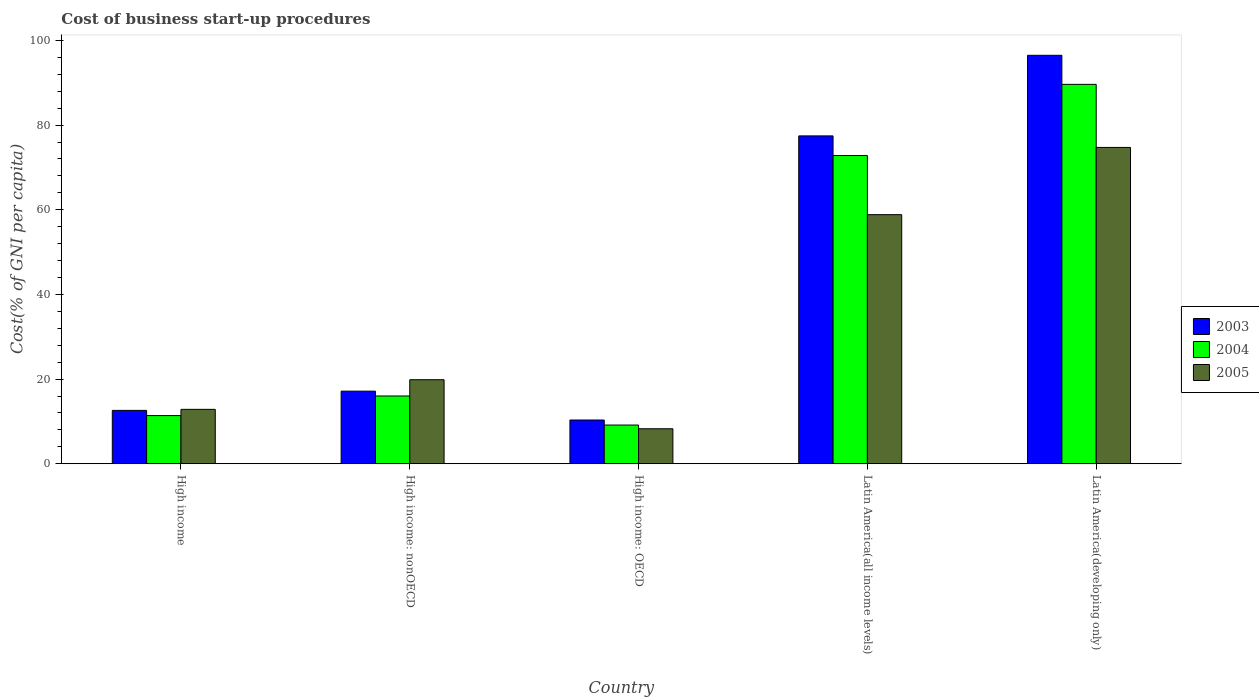Are the number of bars per tick equal to the number of legend labels?
Your answer should be very brief. Yes. Are the number of bars on each tick of the X-axis equal?
Your response must be concise. Yes. What is the cost of business start-up procedures in 2005 in High income: OECD?
Offer a terse response. 8.27. Across all countries, what is the maximum cost of business start-up procedures in 2005?
Make the answer very short. 74.73. Across all countries, what is the minimum cost of business start-up procedures in 2005?
Provide a short and direct response. 8.27. In which country was the cost of business start-up procedures in 2005 maximum?
Your answer should be very brief. Latin America(developing only). In which country was the cost of business start-up procedures in 2004 minimum?
Provide a succinct answer. High income: OECD. What is the total cost of business start-up procedures in 2003 in the graph?
Provide a succinct answer. 214.03. What is the difference between the cost of business start-up procedures in 2005 in High income and that in Latin America(all income levels)?
Make the answer very short. -45.99. What is the difference between the cost of business start-up procedures in 2003 in High income and the cost of business start-up procedures in 2005 in Latin America(developing only)?
Give a very brief answer. -62.12. What is the average cost of business start-up procedures in 2005 per country?
Ensure brevity in your answer.  34.91. What is the difference between the cost of business start-up procedures of/in 2005 and cost of business start-up procedures of/in 2004 in High income?
Offer a terse response. 1.47. What is the ratio of the cost of business start-up procedures in 2003 in High income to that in Latin America(developing only)?
Keep it short and to the point. 0.13. Is the cost of business start-up procedures in 2005 in High income: nonOECD less than that in Latin America(developing only)?
Give a very brief answer. Yes. What is the difference between the highest and the second highest cost of business start-up procedures in 2003?
Give a very brief answer. 79.34. What is the difference between the highest and the lowest cost of business start-up procedures in 2005?
Make the answer very short. 66.46. In how many countries, is the cost of business start-up procedures in 2004 greater than the average cost of business start-up procedures in 2004 taken over all countries?
Give a very brief answer. 2. What does the 2nd bar from the right in High income represents?
Offer a terse response. 2004. Is it the case that in every country, the sum of the cost of business start-up procedures in 2003 and cost of business start-up procedures in 2005 is greater than the cost of business start-up procedures in 2004?
Provide a succinct answer. Yes. How many bars are there?
Give a very brief answer. 15. Are the values on the major ticks of Y-axis written in scientific E-notation?
Offer a terse response. No. Does the graph contain grids?
Your answer should be very brief. No. How many legend labels are there?
Your response must be concise. 3. How are the legend labels stacked?
Provide a succinct answer. Vertical. What is the title of the graph?
Offer a terse response. Cost of business start-up procedures. Does "1973" appear as one of the legend labels in the graph?
Your answer should be compact. No. What is the label or title of the X-axis?
Give a very brief answer. Country. What is the label or title of the Y-axis?
Ensure brevity in your answer.  Cost(% of GNI per capita). What is the Cost(% of GNI per capita) in 2003 in High income?
Your response must be concise. 12.6. What is the Cost(% of GNI per capita) in 2004 in High income?
Provide a short and direct response. 11.38. What is the Cost(% of GNI per capita) of 2005 in High income?
Provide a succinct answer. 12.85. What is the Cost(% of GNI per capita) of 2003 in High income: nonOECD?
Keep it short and to the point. 17.15. What is the Cost(% of GNI per capita) of 2004 in High income: nonOECD?
Provide a succinct answer. 16.01. What is the Cost(% of GNI per capita) of 2005 in High income: nonOECD?
Your answer should be very brief. 19.85. What is the Cost(% of GNI per capita) in 2003 in High income: OECD?
Your answer should be compact. 10.33. What is the Cost(% of GNI per capita) of 2004 in High income: OECD?
Offer a terse response. 9.14. What is the Cost(% of GNI per capita) of 2005 in High income: OECD?
Ensure brevity in your answer.  8.27. What is the Cost(% of GNI per capita) in 2003 in Latin America(all income levels)?
Your answer should be compact. 77.45. What is the Cost(% of GNI per capita) of 2004 in Latin America(all income levels)?
Give a very brief answer. 72.81. What is the Cost(% of GNI per capita) in 2005 in Latin America(all income levels)?
Make the answer very short. 58.84. What is the Cost(% of GNI per capita) of 2003 in Latin America(developing only)?
Offer a terse response. 96.49. What is the Cost(% of GNI per capita) of 2004 in Latin America(developing only)?
Provide a succinct answer. 89.63. What is the Cost(% of GNI per capita) of 2005 in Latin America(developing only)?
Your response must be concise. 74.73. Across all countries, what is the maximum Cost(% of GNI per capita) in 2003?
Provide a short and direct response. 96.49. Across all countries, what is the maximum Cost(% of GNI per capita) in 2004?
Provide a succinct answer. 89.63. Across all countries, what is the maximum Cost(% of GNI per capita) of 2005?
Provide a succinct answer. 74.73. Across all countries, what is the minimum Cost(% of GNI per capita) in 2003?
Your response must be concise. 10.33. Across all countries, what is the minimum Cost(% of GNI per capita) of 2004?
Provide a succinct answer. 9.14. Across all countries, what is the minimum Cost(% of GNI per capita) of 2005?
Ensure brevity in your answer.  8.27. What is the total Cost(% of GNI per capita) in 2003 in the graph?
Give a very brief answer. 214.03. What is the total Cost(% of GNI per capita) in 2004 in the graph?
Your answer should be very brief. 198.96. What is the total Cost(% of GNI per capita) of 2005 in the graph?
Offer a very short reply. 174.53. What is the difference between the Cost(% of GNI per capita) of 2003 in High income and that in High income: nonOECD?
Offer a terse response. -4.55. What is the difference between the Cost(% of GNI per capita) in 2004 in High income and that in High income: nonOECD?
Your response must be concise. -4.63. What is the difference between the Cost(% of GNI per capita) of 2005 in High income and that in High income: nonOECD?
Provide a short and direct response. -7. What is the difference between the Cost(% of GNI per capita) in 2003 in High income and that in High income: OECD?
Keep it short and to the point. 2.27. What is the difference between the Cost(% of GNI per capita) in 2004 in High income and that in High income: OECD?
Give a very brief answer. 2.24. What is the difference between the Cost(% of GNI per capita) of 2005 in High income and that in High income: OECD?
Your answer should be compact. 4.58. What is the difference between the Cost(% of GNI per capita) of 2003 in High income and that in Latin America(all income levels)?
Provide a short and direct response. -64.85. What is the difference between the Cost(% of GNI per capita) in 2004 in High income and that in Latin America(all income levels)?
Keep it short and to the point. -61.43. What is the difference between the Cost(% of GNI per capita) of 2005 in High income and that in Latin America(all income levels)?
Give a very brief answer. -45.99. What is the difference between the Cost(% of GNI per capita) of 2003 in High income and that in Latin America(developing only)?
Your answer should be very brief. -83.89. What is the difference between the Cost(% of GNI per capita) of 2004 in High income and that in Latin America(developing only)?
Offer a very short reply. -78.25. What is the difference between the Cost(% of GNI per capita) of 2005 in High income and that in Latin America(developing only)?
Your response must be concise. -61.88. What is the difference between the Cost(% of GNI per capita) of 2003 in High income: nonOECD and that in High income: OECD?
Offer a terse response. 6.82. What is the difference between the Cost(% of GNI per capita) of 2004 in High income: nonOECD and that in High income: OECD?
Provide a succinct answer. 6.87. What is the difference between the Cost(% of GNI per capita) of 2005 in High income: nonOECD and that in High income: OECD?
Give a very brief answer. 11.58. What is the difference between the Cost(% of GNI per capita) in 2003 in High income: nonOECD and that in Latin America(all income levels)?
Keep it short and to the point. -60.3. What is the difference between the Cost(% of GNI per capita) of 2004 in High income: nonOECD and that in Latin America(all income levels)?
Offer a very short reply. -56.8. What is the difference between the Cost(% of GNI per capita) in 2005 in High income: nonOECD and that in Latin America(all income levels)?
Make the answer very short. -38.99. What is the difference between the Cost(% of GNI per capita) of 2003 in High income: nonOECD and that in Latin America(developing only)?
Your answer should be very brief. -79.34. What is the difference between the Cost(% of GNI per capita) of 2004 in High income: nonOECD and that in Latin America(developing only)?
Keep it short and to the point. -73.62. What is the difference between the Cost(% of GNI per capita) of 2005 in High income: nonOECD and that in Latin America(developing only)?
Make the answer very short. -54.88. What is the difference between the Cost(% of GNI per capita) of 2003 in High income: OECD and that in Latin America(all income levels)?
Ensure brevity in your answer.  -67.12. What is the difference between the Cost(% of GNI per capita) of 2004 in High income: OECD and that in Latin America(all income levels)?
Offer a very short reply. -63.67. What is the difference between the Cost(% of GNI per capita) in 2005 in High income: OECD and that in Latin America(all income levels)?
Provide a short and direct response. -50.58. What is the difference between the Cost(% of GNI per capita) in 2003 in High income: OECD and that in Latin America(developing only)?
Offer a terse response. -86.16. What is the difference between the Cost(% of GNI per capita) of 2004 in High income: OECD and that in Latin America(developing only)?
Offer a very short reply. -80.49. What is the difference between the Cost(% of GNI per capita) of 2005 in High income: OECD and that in Latin America(developing only)?
Keep it short and to the point. -66.46. What is the difference between the Cost(% of GNI per capita) of 2003 in Latin America(all income levels) and that in Latin America(developing only)?
Ensure brevity in your answer.  -19.04. What is the difference between the Cost(% of GNI per capita) in 2004 in Latin America(all income levels) and that in Latin America(developing only)?
Provide a succinct answer. -16.82. What is the difference between the Cost(% of GNI per capita) of 2005 in Latin America(all income levels) and that in Latin America(developing only)?
Offer a terse response. -15.89. What is the difference between the Cost(% of GNI per capita) in 2003 in High income and the Cost(% of GNI per capita) in 2004 in High income: nonOECD?
Offer a terse response. -3.4. What is the difference between the Cost(% of GNI per capita) in 2003 in High income and the Cost(% of GNI per capita) in 2005 in High income: nonOECD?
Ensure brevity in your answer.  -7.24. What is the difference between the Cost(% of GNI per capita) of 2004 in High income and the Cost(% of GNI per capita) of 2005 in High income: nonOECD?
Ensure brevity in your answer.  -8.47. What is the difference between the Cost(% of GNI per capita) of 2003 in High income and the Cost(% of GNI per capita) of 2004 in High income: OECD?
Make the answer very short. 3.46. What is the difference between the Cost(% of GNI per capita) in 2003 in High income and the Cost(% of GNI per capita) in 2005 in High income: OECD?
Offer a very short reply. 4.34. What is the difference between the Cost(% of GNI per capita) in 2004 in High income and the Cost(% of GNI per capita) in 2005 in High income: OECD?
Provide a succinct answer. 3.11. What is the difference between the Cost(% of GNI per capita) of 2003 in High income and the Cost(% of GNI per capita) of 2004 in Latin America(all income levels)?
Give a very brief answer. -60.21. What is the difference between the Cost(% of GNI per capita) of 2003 in High income and the Cost(% of GNI per capita) of 2005 in Latin America(all income levels)?
Provide a short and direct response. -46.24. What is the difference between the Cost(% of GNI per capita) in 2004 in High income and the Cost(% of GNI per capita) in 2005 in Latin America(all income levels)?
Give a very brief answer. -47.46. What is the difference between the Cost(% of GNI per capita) of 2003 in High income and the Cost(% of GNI per capita) of 2004 in Latin America(developing only)?
Give a very brief answer. -77.02. What is the difference between the Cost(% of GNI per capita) of 2003 in High income and the Cost(% of GNI per capita) of 2005 in Latin America(developing only)?
Your response must be concise. -62.12. What is the difference between the Cost(% of GNI per capita) of 2004 in High income and the Cost(% of GNI per capita) of 2005 in Latin America(developing only)?
Your answer should be compact. -63.35. What is the difference between the Cost(% of GNI per capita) in 2003 in High income: nonOECD and the Cost(% of GNI per capita) in 2004 in High income: OECD?
Offer a very short reply. 8.01. What is the difference between the Cost(% of GNI per capita) of 2003 in High income: nonOECD and the Cost(% of GNI per capita) of 2005 in High income: OECD?
Your answer should be very brief. 8.88. What is the difference between the Cost(% of GNI per capita) in 2004 in High income: nonOECD and the Cost(% of GNI per capita) in 2005 in High income: OECD?
Provide a short and direct response. 7.74. What is the difference between the Cost(% of GNI per capita) in 2003 in High income: nonOECD and the Cost(% of GNI per capita) in 2004 in Latin America(all income levels)?
Offer a very short reply. -55.66. What is the difference between the Cost(% of GNI per capita) of 2003 in High income: nonOECD and the Cost(% of GNI per capita) of 2005 in Latin America(all income levels)?
Your answer should be very brief. -41.69. What is the difference between the Cost(% of GNI per capita) of 2004 in High income: nonOECD and the Cost(% of GNI per capita) of 2005 in Latin America(all income levels)?
Your answer should be very brief. -42.83. What is the difference between the Cost(% of GNI per capita) of 2003 in High income: nonOECD and the Cost(% of GNI per capita) of 2004 in Latin America(developing only)?
Your response must be concise. -72.48. What is the difference between the Cost(% of GNI per capita) of 2003 in High income: nonOECD and the Cost(% of GNI per capita) of 2005 in Latin America(developing only)?
Provide a short and direct response. -57.58. What is the difference between the Cost(% of GNI per capita) of 2004 in High income: nonOECD and the Cost(% of GNI per capita) of 2005 in Latin America(developing only)?
Ensure brevity in your answer.  -58.72. What is the difference between the Cost(% of GNI per capita) in 2003 in High income: OECD and the Cost(% of GNI per capita) in 2004 in Latin America(all income levels)?
Provide a short and direct response. -62.48. What is the difference between the Cost(% of GNI per capita) of 2003 in High income: OECD and the Cost(% of GNI per capita) of 2005 in Latin America(all income levels)?
Offer a very short reply. -48.51. What is the difference between the Cost(% of GNI per capita) in 2004 in High income: OECD and the Cost(% of GNI per capita) in 2005 in Latin America(all income levels)?
Your answer should be very brief. -49.7. What is the difference between the Cost(% of GNI per capita) of 2003 in High income: OECD and the Cost(% of GNI per capita) of 2004 in Latin America(developing only)?
Your response must be concise. -79.29. What is the difference between the Cost(% of GNI per capita) of 2003 in High income: OECD and the Cost(% of GNI per capita) of 2005 in Latin America(developing only)?
Provide a short and direct response. -64.4. What is the difference between the Cost(% of GNI per capita) in 2004 in High income: OECD and the Cost(% of GNI per capita) in 2005 in Latin America(developing only)?
Provide a short and direct response. -65.59. What is the difference between the Cost(% of GNI per capita) in 2003 in Latin America(all income levels) and the Cost(% of GNI per capita) in 2004 in Latin America(developing only)?
Provide a succinct answer. -12.17. What is the difference between the Cost(% of GNI per capita) in 2003 in Latin America(all income levels) and the Cost(% of GNI per capita) in 2005 in Latin America(developing only)?
Your answer should be very brief. 2.72. What is the difference between the Cost(% of GNI per capita) in 2004 in Latin America(all income levels) and the Cost(% of GNI per capita) in 2005 in Latin America(developing only)?
Offer a very short reply. -1.92. What is the average Cost(% of GNI per capita) of 2003 per country?
Your answer should be compact. 42.81. What is the average Cost(% of GNI per capita) in 2004 per country?
Your answer should be very brief. 39.79. What is the average Cost(% of GNI per capita) of 2005 per country?
Give a very brief answer. 34.91. What is the difference between the Cost(% of GNI per capita) in 2003 and Cost(% of GNI per capita) in 2004 in High income?
Your answer should be compact. 1.23. What is the difference between the Cost(% of GNI per capita) in 2003 and Cost(% of GNI per capita) in 2005 in High income?
Provide a short and direct response. -0.25. What is the difference between the Cost(% of GNI per capita) in 2004 and Cost(% of GNI per capita) in 2005 in High income?
Provide a short and direct response. -1.47. What is the difference between the Cost(% of GNI per capita) of 2003 and Cost(% of GNI per capita) of 2005 in High income: nonOECD?
Offer a very short reply. -2.7. What is the difference between the Cost(% of GNI per capita) in 2004 and Cost(% of GNI per capita) in 2005 in High income: nonOECD?
Make the answer very short. -3.84. What is the difference between the Cost(% of GNI per capita) in 2003 and Cost(% of GNI per capita) in 2004 in High income: OECD?
Keep it short and to the point. 1.19. What is the difference between the Cost(% of GNI per capita) in 2003 and Cost(% of GNI per capita) in 2005 in High income: OECD?
Your answer should be very brief. 2.07. What is the difference between the Cost(% of GNI per capita) in 2004 and Cost(% of GNI per capita) in 2005 in High income: OECD?
Offer a terse response. 0.88. What is the difference between the Cost(% of GNI per capita) of 2003 and Cost(% of GNI per capita) of 2004 in Latin America(all income levels)?
Offer a terse response. 4.64. What is the difference between the Cost(% of GNI per capita) of 2003 and Cost(% of GNI per capita) of 2005 in Latin America(all income levels)?
Your answer should be compact. 18.61. What is the difference between the Cost(% of GNI per capita) in 2004 and Cost(% of GNI per capita) in 2005 in Latin America(all income levels)?
Provide a short and direct response. 13.97. What is the difference between the Cost(% of GNI per capita) in 2003 and Cost(% of GNI per capita) in 2004 in Latin America(developing only)?
Your answer should be very brief. 6.87. What is the difference between the Cost(% of GNI per capita) in 2003 and Cost(% of GNI per capita) in 2005 in Latin America(developing only)?
Give a very brief answer. 21.76. What is the difference between the Cost(% of GNI per capita) in 2004 and Cost(% of GNI per capita) in 2005 in Latin America(developing only)?
Keep it short and to the point. 14.9. What is the ratio of the Cost(% of GNI per capita) in 2003 in High income to that in High income: nonOECD?
Ensure brevity in your answer.  0.73. What is the ratio of the Cost(% of GNI per capita) in 2004 in High income to that in High income: nonOECD?
Make the answer very short. 0.71. What is the ratio of the Cost(% of GNI per capita) in 2005 in High income to that in High income: nonOECD?
Your answer should be very brief. 0.65. What is the ratio of the Cost(% of GNI per capita) in 2003 in High income to that in High income: OECD?
Your response must be concise. 1.22. What is the ratio of the Cost(% of GNI per capita) in 2004 in High income to that in High income: OECD?
Your answer should be compact. 1.24. What is the ratio of the Cost(% of GNI per capita) of 2005 in High income to that in High income: OECD?
Your answer should be very brief. 1.55. What is the ratio of the Cost(% of GNI per capita) in 2003 in High income to that in Latin America(all income levels)?
Make the answer very short. 0.16. What is the ratio of the Cost(% of GNI per capita) of 2004 in High income to that in Latin America(all income levels)?
Your response must be concise. 0.16. What is the ratio of the Cost(% of GNI per capita) of 2005 in High income to that in Latin America(all income levels)?
Ensure brevity in your answer.  0.22. What is the ratio of the Cost(% of GNI per capita) of 2003 in High income to that in Latin America(developing only)?
Your answer should be very brief. 0.13. What is the ratio of the Cost(% of GNI per capita) in 2004 in High income to that in Latin America(developing only)?
Offer a very short reply. 0.13. What is the ratio of the Cost(% of GNI per capita) in 2005 in High income to that in Latin America(developing only)?
Your answer should be compact. 0.17. What is the ratio of the Cost(% of GNI per capita) of 2003 in High income: nonOECD to that in High income: OECD?
Offer a terse response. 1.66. What is the ratio of the Cost(% of GNI per capita) in 2004 in High income: nonOECD to that in High income: OECD?
Your answer should be compact. 1.75. What is the ratio of the Cost(% of GNI per capita) in 2005 in High income: nonOECD to that in High income: OECD?
Ensure brevity in your answer.  2.4. What is the ratio of the Cost(% of GNI per capita) of 2003 in High income: nonOECD to that in Latin America(all income levels)?
Provide a succinct answer. 0.22. What is the ratio of the Cost(% of GNI per capita) of 2004 in High income: nonOECD to that in Latin America(all income levels)?
Provide a short and direct response. 0.22. What is the ratio of the Cost(% of GNI per capita) of 2005 in High income: nonOECD to that in Latin America(all income levels)?
Make the answer very short. 0.34. What is the ratio of the Cost(% of GNI per capita) of 2003 in High income: nonOECD to that in Latin America(developing only)?
Ensure brevity in your answer.  0.18. What is the ratio of the Cost(% of GNI per capita) of 2004 in High income: nonOECD to that in Latin America(developing only)?
Give a very brief answer. 0.18. What is the ratio of the Cost(% of GNI per capita) of 2005 in High income: nonOECD to that in Latin America(developing only)?
Your response must be concise. 0.27. What is the ratio of the Cost(% of GNI per capita) in 2003 in High income: OECD to that in Latin America(all income levels)?
Your response must be concise. 0.13. What is the ratio of the Cost(% of GNI per capita) in 2004 in High income: OECD to that in Latin America(all income levels)?
Your response must be concise. 0.13. What is the ratio of the Cost(% of GNI per capita) in 2005 in High income: OECD to that in Latin America(all income levels)?
Ensure brevity in your answer.  0.14. What is the ratio of the Cost(% of GNI per capita) of 2003 in High income: OECD to that in Latin America(developing only)?
Provide a short and direct response. 0.11. What is the ratio of the Cost(% of GNI per capita) in 2004 in High income: OECD to that in Latin America(developing only)?
Offer a terse response. 0.1. What is the ratio of the Cost(% of GNI per capita) of 2005 in High income: OECD to that in Latin America(developing only)?
Offer a terse response. 0.11. What is the ratio of the Cost(% of GNI per capita) of 2003 in Latin America(all income levels) to that in Latin America(developing only)?
Give a very brief answer. 0.8. What is the ratio of the Cost(% of GNI per capita) of 2004 in Latin America(all income levels) to that in Latin America(developing only)?
Your answer should be compact. 0.81. What is the ratio of the Cost(% of GNI per capita) of 2005 in Latin America(all income levels) to that in Latin America(developing only)?
Your response must be concise. 0.79. What is the difference between the highest and the second highest Cost(% of GNI per capita) of 2003?
Your response must be concise. 19.04. What is the difference between the highest and the second highest Cost(% of GNI per capita) of 2004?
Offer a very short reply. 16.82. What is the difference between the highest and the second highest Cost(% of GNI per capita) in 2005?
Your answer should be very brief. 15.89. What is the difference between the highest and the lowest Cost(% of GNI per capita) in 2003?
Provide a succinct answer. 86.16. What is the difference between the highest and the lowest Cost(% of GNI per capita) of 2004?
Your answer should be compact. 80.49. What is the difference between the highest and the lowest Cost(% of GNI per capita) in 2005?
Your answer should be compact. 66.46. 